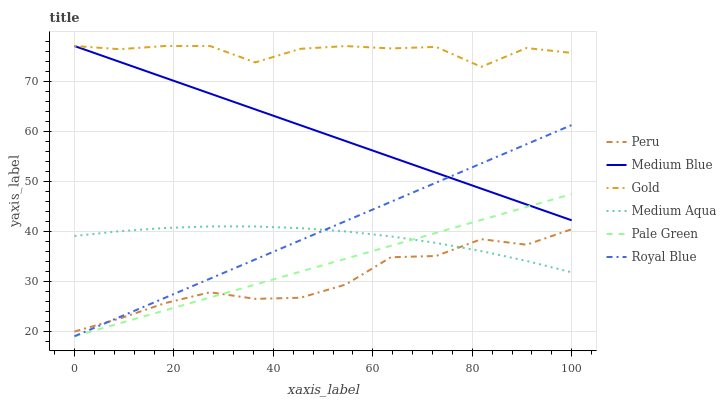Does Peru have the minimum area under the curve?
Answer yes or no. Yes. Does Gold have the maximum area under the curve?
Answer yes or no. Yes. Does Medium Blue have the minimum area under the curve?
Answer yes or no. No. Does Medium Blue have the maximum area under the curve?
Answer yes or no. No. Is Pale Green the smoothest?
Answer yes or no. Yes. Is Gold the roughest?
Answer yes or no. Yes. Is Medium Blue the smoothest?
Answer yes or no. No. Is Medium Blue the roughest?
Answer yes or no. No. Does Royal Blue have the lowest value?
Answer yes or no. Yes. Does Medium Blue have the lowest value?
Answer yes or no. No. Does Medium Blue have the highest value?
Answer yes or no. Yes. Does Royal Blue have the highest value?
Answer yes or no. No. Is Medium Aqua less than Medium Blue?
Answer yes or no. Yes. Is Gold greater than Pale Green?
Answer yes or no. Yes. Does Peru intersect Pale Green?
Answer yes or no. Yes. Is Peru less than Pale Green?
Answer yes or no. No. Is Peru greater than Pale Green?
Answer yes or no. No. Does Medium Aqua intersect Medium Blue?
Answer yes or no. No. 